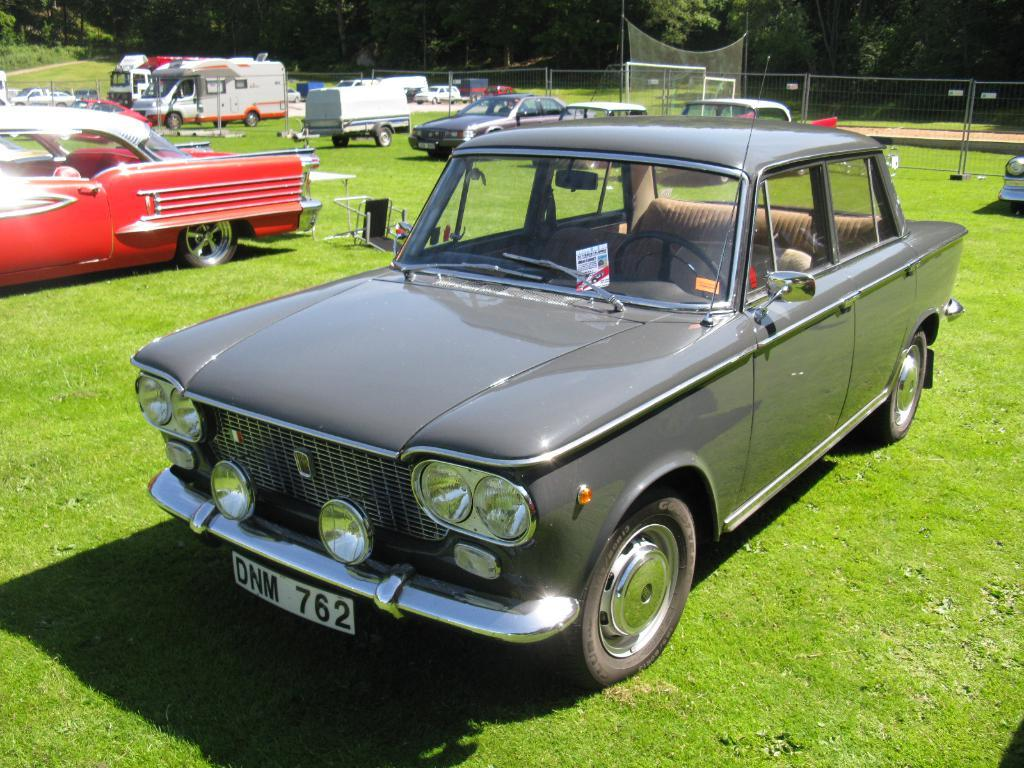What is on the grass path in the image? There are vehicles and objects on the grass path in the image. What is located behind the vehicles in the image? There is a fence, a net, and trees behind the vehicles in the image. Can you describe the objects on the grass path? The provided facts do not specify the nature of the objects on the grass path. What type of office can be seen in the image? There is no office present in the image. Is there a spy observing the vehicles in the image? There is no indication of a spy in the image. 